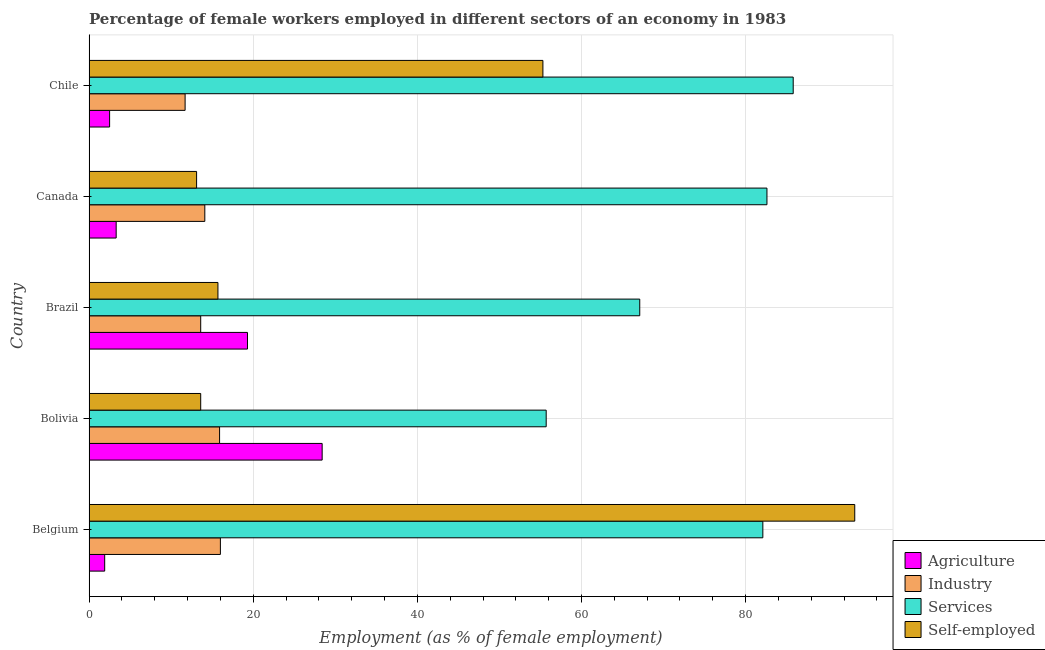How many groups of bars are there?
Your answer should be compact. 5. Are the number of bars per tick equal to the number of legend labels?
Provide a succinct answer. Yes. How many bars are there on the 4th tick from the bottom?
Your answer should be very brief. 4. In how many cases, is the number of bars for a given country not equal to the number of legend labels?
Make the answer very short. 0. Across all countries, what is the maximum percentage of female workers in services?
Give a very brief answer. 85.8. Across all countries, what is the minimum percentage of self employed female workers?
Provide a short and direct response. 13.1. What is the total percentage of female workers in agriculture in the graph?
Ensure brevity in your answer.  55.4. What is the difference between the percentage of female workers in services in Brazil and that in Canada?
Make the answer very short. -15.5. What is the difference between the percentage of female workers in agriculture in Brazil and the percentage of female workers in services in Chile?
Your answer should be compact. -66.5. What is the average percentage of female workers in agriculture per country?
Your response must be concise. 11.08. In how many countries, is the percentage of female workers in agriculture greater than 8 %?
Offer a terse response. 2. What is the ratio of the percentage of self employed female workers in Belgium to that in Canada?
Your answer should be very brief. 7.12. What is the difference between the highest and the second highest percentage of self employed female workers?
Provide a succinct answer. 38. What is the difference between the highest and the lowest percentage of self employed female workers?
Provide a short and direct response. 80.2. Is it the case that in every country, the sum of the percentage of female workers in services and percentage of female workers in agriculture is greater than the sum of percentage of self employed female workers and percentage of female workers in industry?
Offer a very short reply. Yes. What does the 1st bar from the top in Belgium represents?
Ensure brevity in your answer.  Self-employed. What does the 1st bar from the bottom in Chile represents?
Make the answer very short. Agriculture. Is it the case that in every country, the sum of the percentage of female workers in agriculture and percentage of female workers in industry is greater than the percentage of female workers in services?
Your answer should be very brief. No. How many bars are there?
Offer a very short reply. 20. What is the difference between two consecutive major ticks on the X-axis?
Provide a short and direct response. 20. Does the graph contain any zero values?
Your answer should be very brief. No. Where does the legend appear in the graph?
Your answer should be very brief. Bottom right. How many legend labels are there?
Ensure brevity in your answer.  4. How are the legend labels stacked?
Offer a very short reply. Vertical. What is the title of the graph?
Offer a very short reply. Percentage of female workers employed in different sectors of an economy in 1983. What is the label or title of the X-axis?
Make the answer very short. Employment (as % of female employment). What is the label or title of the Y-axis?
Your response must be concise. Country. What is the Employment (as % of female employment) in Agriculture in Belgium?
Your answer should be compact. 1.9. What is the Employment (as % of female employment) of Services in Belgium?
Your response must be concise. 82.1. What is the Employment (as % of female employment) in Self-employed in Belgium?
Your response must be concise. 93.3. What is the Employment (as % of female employment) in Agriculture in Bolivia?
Your response must be concise. 28.4. What is the Employment (as % of female employment) of Industry in Bolivia?
Your response must be concise. 15.9. What is the Employment (as % of female employment) of Services in Bolivia?
Your response must be concise. 55.7. What is the Employment (as % of female employment) of Self-employed in Bolivia?
Keep it short and to the point. 13.6. What is the Employment (as % of female employment) in Agriculture in Brazil?
Offer a terse response. 19.3. What is the Employment (as % of female employment) of Industry in Brazil?
Make the answer very short. 13.6. What is the Employment (as % of female employment) of Services in Brazil?
Your answer should be compact. 67.1. What is the Employment (as % of female employment) of Self-employed in Brazil?
Your answer should be compact. 15.7. What is the Employment (as % of female employment) of Agriculture in Canada?
Keep it short and to the point. 3.3. What is the Employment (as % of female employment) in Industry in Canada?
Provide a succinct answer. 14.1. What is the Employment (as % of female employment) in Services in Canada?
Ensure brevity in your answer.  82.6. What is the Employment (as % of female employment) of Self-employed in Canada?
Your response must be concise. 13.1. What is the Employment (as % of female employment) of Industry in Chile?
Provide a succinct answer. 11.7. What is the Employment (as % of female employment) in Services in Chile?
Provide a short and direct response. 85.8. What is the Employment (as % of female employment) of Self-employed in Chile?
Your answer should be compact. 55.3. Across all countries, what is the maximum Employment (as % of female employment) of Agriculture?
Offer a terse response. 28.4. Across all countries, what is the maximum Employment (as % of female employment) in Industry?
Give a very brief answer. 16. Across all countries, what is the maximum Employment (as % of female employment) in Services?
Ensure brevity in your answer.  85.8. Across all countries, what is the maximum Employment (as % of female employment) of Self-employed?
Provide a succinct answer. 93.3. Across all countries, what is the minimum Employment (as % of female employment) in Agriculture?
Keep it short and to the point. 1.9. Across all countries, what is the minimum Employment (as % of female employment) of Industry?
Offer a terse response. 11.7. Across all countries, what is the minimum Employment (as % of female employment) in Services?
Make the answer very short. 55.7. Across all countries, what is the minimum Employment (as % of female employment) in Self-employed?
Offer a terse response. 13.1. What is the total Employment (as % of female employment) of Agriculture in the graph?
Make the answer very short. 55.4. What is the total Employment (as % of female employment) of Industry in the graph?
Offer a terse response. 71.3. What is the total Employment (as % of female employment) in Services in the graph?
Ensure brevity in your answer.  373.3. What is the total Employment (as % of female employment) of Self-employed in the graph?
Make the answer very short. 191. What is the difference between the Employment (as % of female employment) of Agriculture in Belgium and that in Bolivia?
Keep it short and to the point. -26.5. What is the difference between the Employment (as % of female employment) in Industry in Belgium and that in Bolivia?
Offer a very short reply. 0.1. What is the difference between the Employment (as % of female employment) of Services in Belgium and that in Bolivia?
Your response must be concise. 26.4. What is the difference between the Employment (as % of female employment) of Self-employed in Belgium and that in Bolivia?
Provide a succinct answer. 79.7. What is the difference between the Employment (as % of female employment) in Agriculture in Belgium and that in Brazil?
Your answer should be compact. -17.4. What is the difference between the Employment (as % of female employment) in Self-employed in Belgium and that in Brazil?
Your response must be concise. 77.6. What is the difference between the Employment (as % of female employment) in Self-employed in Belgium and that in Canada?
Provide a succinct answer. 80.2. What is the difference between the Employment (as % of female employment) of Agriculture in Belgium and that in Chile?
Your answer should be very brief. -0.6. What is the difference between the Employment (as % of female employment) of Industry in Belgium and that in Chile?
Keep it short and to the point. 4.3. What is the difference between the Employment (as % of female employment) in Self-employed in Belgium and that in Chile?
Make the answer very short. 38. What is the difference between the Employment (as % of female employment) in Industry in Bolivia and that in Brazil?
Keep it short and to the point. 2.3. What is the difference between the Employment (as % of female employment) in Self-employed in Bolivia and that in Brazil?
Ensure brevity in your answer.  -2.1. What is the difference between the Employment (as % of female employment) in Agriculture in Bolivia and that in Canada?
Keep it short and to the point. 25.1. What is the difference between the Employment (as % of female employment) in Services in Bolivia and that in Canada?
Provide a short and direct response. -26.9. What is the difference between the Employment (as % of female employment) of Self-employed in Bolivia and that in Canada?
Your answer should be compact. 0.5. What is the difference between the Employment (as % of female employment) in Agriculture in Bolivia and that in Chile?
Keep it short and to the point. 25.9. What is the difference between the Employment (as % of female employment) in Services in Bolivia and that in Chile?
Give a very brief answer. -30.1. What is the difference between the Employment (as % of female employment) in Self-employed in Bolivia and that in Chile?
Offer a terse response. -41.7. What is the difference between the Employment (as % of female employment) in Agriculture in Brazil and that in Canada?
Your response must be concise. 16. What is the difference between the Employment (as % of female employment) of Services in Brazil and that in Canada?
Provide a short and direct response. -15.5. What is the difference between the Employment (as % of female employment) of Agriculture in Brazil and that in Chile?
Provide a succinct answer. 16.8. What is the difference between the Employment (as % of female employment) in Industry in Brazil and that in Chile?
Your response must be concise. 1.9. What is the difference between the Employment (as % of female employment) in Services in Brazil and that in Chile?
Keep it short and to the point. -18.7. What is the difference between the Employment (as % of female employment) of Self-employed in Brazil and that in Chile?
Your answer should be compact. -39.6. What is the difference between the Employment (as % of female employment) in Agriculture in Canada and that in Chile?
Ensure brevity in your answer.  0.8. What is the difference between the Employment (as % of female employment) of Industry in Canada and that in Chile?
Provide a short and direct response. 2.4. What is the difference between the Employment (as % of female employment) of Services in Canada and that in Chile?
Your response must be concise. -3.2. What is the difference between the Employment (as % of female employment) in Self-employed in Canada and that in Chile?
Provide a short and direct response. -42.2. What is the difference between the Employment (as % of female employment) of Agriculture in Belgium and the Employment (as % of female employment) of Services in Bolivia?
Ensure brevity in your answer.  -53.8. What is the difference between the Employment (as % of female employment) in Agriculture in Belgium and the Employment (as % of female employment) in Self-employed in Bolivia?
Make the answer very short. -11.7. What is the difference between the Employment (as % of female employment) of Industry in Belgium and the Employment (as % of female employment) of Services in Bolivia?
Your answer should be very brief. -39.7. What is the difference between the Employment (as % of female employment) in Industry in Belgium and the Employment (as % of female employment) in Self-employed in Bolivia?
Offer a terse response. 2.4. What is the difference between the Employment (as % of female employment) of Services in Belgium and the Employment (as % of female employment) of Self-employed in Bolivia?
Offer a very short reply. 68.5. What is the difference between the Employment (as % of female employment) in Agriculture in Belgium and the Employment (as % of female employment) in Industry in Brazil?
Provide a succinct answer. -11.7. What is the difference between the Employment (as % of female employment) in Agriculture in Belgium and the Employment (as % of female employment) in Services in Brazil?
Make the answer very short. -65.2. What is the difference between the Employment (as % of female employment) of Industry in Belgium and the Employment (as % of female employment) of Services in Brazil?
Your response must be concise. -51.1. What is the difference between the Employment (as % of female employment) of Industry in Belgium and the Employment (as % of female employment) of Self-employed in Brazil?
Provide a short and direct response. 0.3. What is the difference between the Employment (as % of female employment) in Services in Belgium and the Employment (as % of female employment) in Self-employed in Brazil?
Offer a terse response. 66.4. What is the difference between the Employment (as % of female employment) in Agriculture in Belgium and the Employment (as % of female employment) in Services in Canada?
Your answer should be very brief. -80.7. What is the difference between the Employment (as % of female employment) of Agriculture in Belgium and the Employment (as % of female employment) of Self-employed in Canada?
Make the answer very short. -11.2. What is the difference between the Employment (as % of female employment) in Industry in Belgium and the Employment (as % of female employment) in Services in Canada?
Provide a succinct answer. -66.6. What is the difference between the Employment (as % of female employment) in Industry in Belgium and the Employment (as % of female employment) in Self-employed in Canada?
Your answer should be very brief. 2.9. What is the difference between the Employment (as % of female employment) of Agriculture in Belgium and the Employment (as % of female employment) of Industry in Chile?
Offer a very short reply. -9.8. What is the difference between the Employment (as % of female employment) in Agriculture in Belgium and the Employment (as % of female employment) in Services in Chile?
Your answer should be compact. -83.9. What is the difference between the Employment (as % of female employment) in Agriculture in Belgium and the Employment (as % of female employment) in Self-employed in Chile?
Your answer should be compact. -53.4. What is the difference between the Employment (as % of female employment) in Industry in Belgium and the Employment (as % of female employment) in Services in Chile?
Offer a very short reply. -69.8. What is the difference between the Employment (as % of female employment) of Industry in Belgium and the Employment (as % of female employment) of Self-employed in Chile?
Provide a succinct answer. -39.3. What is the difference between the Employment (as % of female employment) of Services in Belgium and the Employment (as % of female employment) of Self-employed in Chile?
Your response must be concise. 26.8. What is the difference between the Employment (as % of female employment) of Agriculture in Bolivia and the Employment (as % of female employment) of Services in Brazil?
Give a very brief answer. -38.7. What is the difference between the Employment (as % of female employment) in Agriculture in Bolivia and the Employment (as % of female employment) in Self-employed in Brazil?
Offer a very short reply. 12.7. What is the difference between the Employment (as % of female employment) in Industry in Bolivia and the Employment (as % of female employment) in Services in Brazil?
Keep it short and to the point. -51.2. What is the difference between the Employment (as % of female employment) of Services in Bolivia and the Employment (as % of female employment) of Self-employed in Brazil?
Provide a succinct answer. 40. What is the difference between the Employment (as % of female employment) in Agriculture in Bolivia and the Employment (as % of female employment) in Services in Canada?
Ensure brevity in your answer.  -54.2. What is the difference between the Employment (as % of female employment) of Industry in Bolivia and the Employment (as % of female employment) of Services in Canada?
Your answer should be very brief. -66.7. What is the difference between the Employment (as % of female employment) of Services in Bolivia and the Employment (as % of female employment) of Self-employed in Canada?
Keep it short and to the point. 42.6. What is the difference between the Employment (as % of female employment) in Agriculture in Bolivia and the Employment (as % of female employment) in Services in Chile?
Provide a succinct answer. -57.4. What is the difference between the Employment (as % of female employment) of Agriculture in Bolivia and the Employment (as % of female employment) of Self-employed in Chile?
Keep it short and to the point. -26.9. What is the difference between the Employment (as % of female employment) in Industry in Bolivia and the Employment (as % of female employment) in Services in Chile?
Offer a terse response. -69.9. What is the difference between the Employment (as % of female employment) of Industry in Bolivia and the Employment (as % of female employment) of Self-employed in Chile?
Your answer should be compact. -39.4. What is the difference between the Employment (as % of female employment) of Agriculture in Brazil and the Employment (as % of female employment) of Services in Canada?
Your response must be concise. -63.3. What is the difference between the Employment (as % of female employment) of Agriculture in Brazil and the Employment (as % of female employment) of Self-employed in Canada?
Your answer should be compact. 6.2. What is the difference between the Employment (as % of female employment) in Industry in Brazil and the Employment (as % of female employment) in Services in Canada?
Make the answer very short. -69. What is the difference between the Employment (as % of female employment) in Industry in Brazil and the Employment (as % of female employment) in Self-employed in Canada?
Ensure brevity in your answer.  0.5. What is the difference between the Employment (as % of female employment) in Services in Brazil and the Employment (as % of female employment) in Self-employed in Canada?
Your answer should be compact. 54. What is the difference between the Employment (as % of female employment) of Agriculture in Brazil and the Employment (as % of female employment) of Industry in Chile?
Your answer should be compact. 7.6. What is the difference between the Employment (as % of female employment) in Agriculture in Brazil and the Employment (as % of female employment) in Services in Chile?
Your answer should be compact. -66.5. What is the difference between the Employment (as % of female employment) of Agriculture in Brazil and the Employment (as % of female employment) of Self-employed in Chile?
Provide a succinct answer. -36. What is the difference between the Employment (as % of female employment) of Industry in Brazil and the Employment (as % of female employment) of Services in Chile?
Offer a very short reply. -72.2. What is the difference between the Employment (as % of female employment) in Industry in Brazil and the Employment (as % of female employment) in Self-employed in Chile?
Give a very brief answer. -41.7. What is the difference between the Employment (as % of female employment) in Agriculture in Canada and the Employment (as % of female employment) in Services in Chile?
Your answer should be very brief. -82.5. What is the difference between the Employment (as % of female employment) in Agriculture in Canada and the Employment (as % of female employment) in Self-employed in Chile?
Your answer should be very brief. -52. What is the difference between the Employment (as % of female employment) of Industry in Canada and the Employment (as % of female employment) of Services in Chile?
Offer a terse response. -71.7. What is the difference between the Employment (as % of female employment) in Industry in Canada and the Employment (as % of female employment) in Self-employed in Chile?
Offer a terse response. -41.2. What is the difference between the Employment (as % of female employment) of Services in Canada and the Employment (as % of female employment) of Self-employed in Chile?
Your answer should be compact. 27.3. What is the average Employment (as % of female employment) of Agriculture per country?
Your answer should be compact. 11.08. What is the average Employment (as % of female employment) in Industry per country?
Your response must be concise. 14.26. What is the average Employment (as % of female employment) of Services per country?
Provide a short and direct response. 74.66. What is the average Employment (as % of female employment) in Self-employed per country?
Offer a very short reply. 38.2. What is the difference between the Employment (as % of female employment) in Agriculture and Employment (as % of female employment) in Industry in Belgium?
Provide a succinct answer. -14.1. What is the difference between the Employment (as % of female employment) of Agriculture and Employment (as % of female employment) of Services in Belgium?
Provide a short and direct response. -80.2. What is the difference between the Employment (as % of female employment) in Agriculture and Employment (as % of female employment) in Self-employed in Belgium?
Offer a terse response. -91.4. What is the difference between the Employment (as % of female employment) in Industry and Employment (as % of female employment) in Services in Belgium?
Your answer should be very brief. -66.1. What is the difference between the Employment (as % of female employment) in Industry and Employment (as % of female employment) in Self-employed in Belgium?
Offer a terse response. -77.3. What is the difference between the Employment (as % of female employment) of Services and Employment (as % of female employment) of Self-employed in Belgium?
Offer a very short reply. -11.2. What is the difference between the Employment (as % of female employment) in Agriculture and Employment (as % of female employment) in Services in Bolivia?
Provide a short and direct response. -27.3. What is the difference between the Employment (as % of female employment) in Agriculture and Employment (as % of female employment) in Self-employed in Bolivia?
Keep it short and to the point. 14.8. What is the difference between the Employment (as % of female employment) in Industry and Employment (as % of female employment) in Services in Bolivia?
Keep it short and to the point. -39.8. What is the difference between the Employment (as % of female employment) in Services and Employment (as % of female employment) in Self-employed in Bolivia?
Your answer should be compact. 42.1. What is the difference between the Employment (as % of female employment) in Agriculture and Employment (as % of female employment) in Services in Brazil?
Your answer should be compact. -47.8. What is the difference between the Employment (as % of female employment) of Industry and Employment (as % of female employment) of Services in Brazil?
Keep it short and to the point. -53.5. What is the difference between the Employment (as % of female employment) in Industry and Employment (as % of female employment) in Self-employed in Brazil?
Your response must be concise. -2.1. What is the difference between the Employment (as % of female employment) in Services and Employment (as % of female employment) in Self-employed in Brazil?
Your response must be concise. 51.4. What is the difference between the Employment (as % of female employment) of Agriculture and Employment (as % of female employment) of Industry in Canada?
Offer a very short reply. -10.8. What is the difference between the Employment (as % of female employment) in Agriculture and Employment (as % of female employment) in Services in Canada?
Your answer should be very brief. -79.3. What is the difference between the Employment (as % of female employment) of Industry and Employment (as % of female employment) of Services in Canada?
Provide a succinct answer. -68.5. What is the difference between the Employment (as % of female employment) in Services and Employment (as % of female employment) in Self-employed in Canada?
Offer a terse response. 69.5. What is the difference between the Employment (as % of female employment) of Agriculture and Employment (as % of female employment) of Services in Chile?
Offer a very short reply. -83.3. What is the difference between the Employment (as % of female employment) in Agriculture and Employment (as % of female employment) in Self-employed in Chile?
Your answer should be very brief. -52.8. What is the difference between the Employment (as % of female employment) of Industry and Employment (as % of female employment) of Services in Chile?
Your answer should be very brief. -74.1. What is the difference between the Employment (as % of female employment) of Industry and Employment (as % of female employment) of Self-employed in Chile?
Your answer should be very brief. -43.6. What is the difference between the Employment (as % of female employment) in Services and Employment (as % of female employment) in Self-employed in Chile?
Offer a terse response. 30.5. What is the ratio of the Employment (as % of female employment) in Agriculture in Belgium to that in Bolivia?
Offer a terse response. 0.07. What is the ratio of the Employment (as % of female employment) in Services in Belgium to that in Bolivia?
Your answer should be compact. 1.47. What is the ratio of the Employment (as % of female employment) in Self-employed in Belgium to that in Bolivia?
Keep it short and to the point. 6.86. What is the ratio of the Employment (as % of female employment) in Agriculture in Belgium to that in Brazil?
Offer a very short reply. 0.1. What is the ratio of the Employment (as % of female employment) of Industry in Belgium to that in Brazil?
Your response must be concise. 1.18. What is the ratio of the Employment (as % of female employment) of Services in Belgium to that in Brazil?
Make the answer very short. 1.22. What is the ratio of the Employment (as % of female employment) in Self-employed in Belgium to that in Brazil?
Your response must be concise. 5.94. What is the ratio of the Employment (as % of female employment) in Agriculture in Belgium to that in Canada?
Give a very brief answer. 0.58. What is the ratio of the Employment (as % of female employment) of Industry in Belgium to that in Canada?
Ensure brevity in your answer.  1.13. What is the ratio of the Employment (as % of female employment) of Services in Belgium to that in Canada?
Ensure brevity in your answer.  0.99. What is the ratio of the Employment (as % of female employment) of Self-employed in Belgium to that in Canada?
Offer a very short reply. 7.12. What is the ratio of the Employment (as % of female employment) in Agriculture in Belgium to that in Chile?
Your answer should be very brief. 0.76. What is the ratio of the Employment (as % of female employment) in Industry in Belgium to that in Chile?
Offer a terse response. 1.37. What is the ratio of the Employment (as % of female employment) of Services in Belgium to that in Chile?
Keep it short and to the point. 0.96. What is the ratio of the Employment (as % of female employment) in Self-employed in Belgium to that in Chile?
Give a very brief answer. 1.69. What is the ratio of the Employment (as % of female employment) of Agriculture in Bolivia to that in Brazil?
Keep it short and to the point. 1.47. What is the ratio of the Employment (as % of female employment) in Industry in Bolivia to that in Brazil?
Offer a very short reply. 1.17. What is the ratio of the Employment (as % of female employment) of Services in Bolivia to that in Brazil?
Give a very brief answer. 0.83. What is the ratio of the Employment (as % of female employment) in Self-employed in Bolivia to that in Brazil?
Ensure brevity in your answer.  0.87. What is the ratio of the Employment (as % of female employment) in Agriculture in Bolivia to that in Canada?
Your answer should be very brief. 8.61. What is the ratio of the Employment (as % of female employment) of Industry in Bolivia to that in Canada?
Your answer should be very brief. 1.13. What is the ratio of the Employment (as % of female employment) of Services in Bolivia to that in Canada?
Your response must be concise. 0.67. What is the ratio of the Employment (as % of female employment) in Self-employed in Bolivia to that in Canada?
Give a very brief answer. 1.04. What is the ratio of the Employment (as % of female employment) of Agriculture in Bolivia to that in Chile?
Provide a short and direct response. 11.36. What is the ratio of the Employment (as % of female employment) of Industry in Bolivia to that in Chile?
Offer a terse response. 1.36. What is the ratio of the Employment (as % of female employment) of Services in Bolivia to that in Chile?
Provide a succinct answer. 0.65. What is the ratio of the Employment (as % of female employment) in Self-employed in Bolivia to that in Chile?
Make the answer very short. 0.25. What is the ratio of the Employment (as % of female employment) in Agriculture in Brazil to that in Canada?
Your response must be concise. 5.85. What is the ratio of the Employment (as % of female employment) in Industry in Brazil to that in Canada?
Ensure brevity in your answer.  0.96. What is the ratio of the Employment (as % of female employment) in Services in Brazil to that in Canada?
Offer a terse response. 0.81. What is the ratio of the Employment (as % of female employment) of Self-employed in Brazil to that in Canada?
Keep it short and to the point. 1.2. What is the ratio of the Employment (as % of female employment) in Agriculture in Brazil to that in Chile?
Offer a terse response. 7.72. What is the ratio of the Employment (as % of female employment) of Industry in Brazil to that in Chile?
Provide a succinct answer. 1.16. What is the ratio of the Employment (as % of female employment) of Services in Brazil to that in Chile?
Make the answer very short. 0.78. What is the ratio of the Employment (as % of female employment) of Self-employed in Brazil to that in Chile?
Offer a very short reply. 0.28. What is the ratio of the Employment (as % of female employment) in Agriculture in Canada to that in Chile?
Make the answer very short. 1.32. What is the ratio of the Employment (as % of female employment) in Industry in Canada to that in Chile?
Give a very brief answer. 1.21. What is the ratio of the Employment (as % of female employment) of Services in Canada to that in Chile?
Make the answer very short. 0.96. What is the ratio of the Employment (as % of female employment) in Self-employed in Canada to that in Chile?
Your answer should be very brief. 0.24. What is the difference between the highest and the second highest Employment (as % of female employment) of Agriculture?
Offer a very short reply. 9.1. What is the difference between the highest and the second highest Employment (as % of female employment) in Services?
Make the answer very short. 3.2. What is the difference between the highest and the second highest Employment (as % of female employment) of Self-employed?
Offer a terse response. 38. What is the difference between the highest and the lowest Employment (as % of female employment) in Agriculture?
Your answer should be very brief. 26.5. What is the difference between the highest and the lowest Employment (as % of female employment) in Services?
Your response must be concise. 30.1. What is the difference between the highest and the lowest Employment (as % of female employment) in Self-employed?
Make the answer very short. 80.2. 